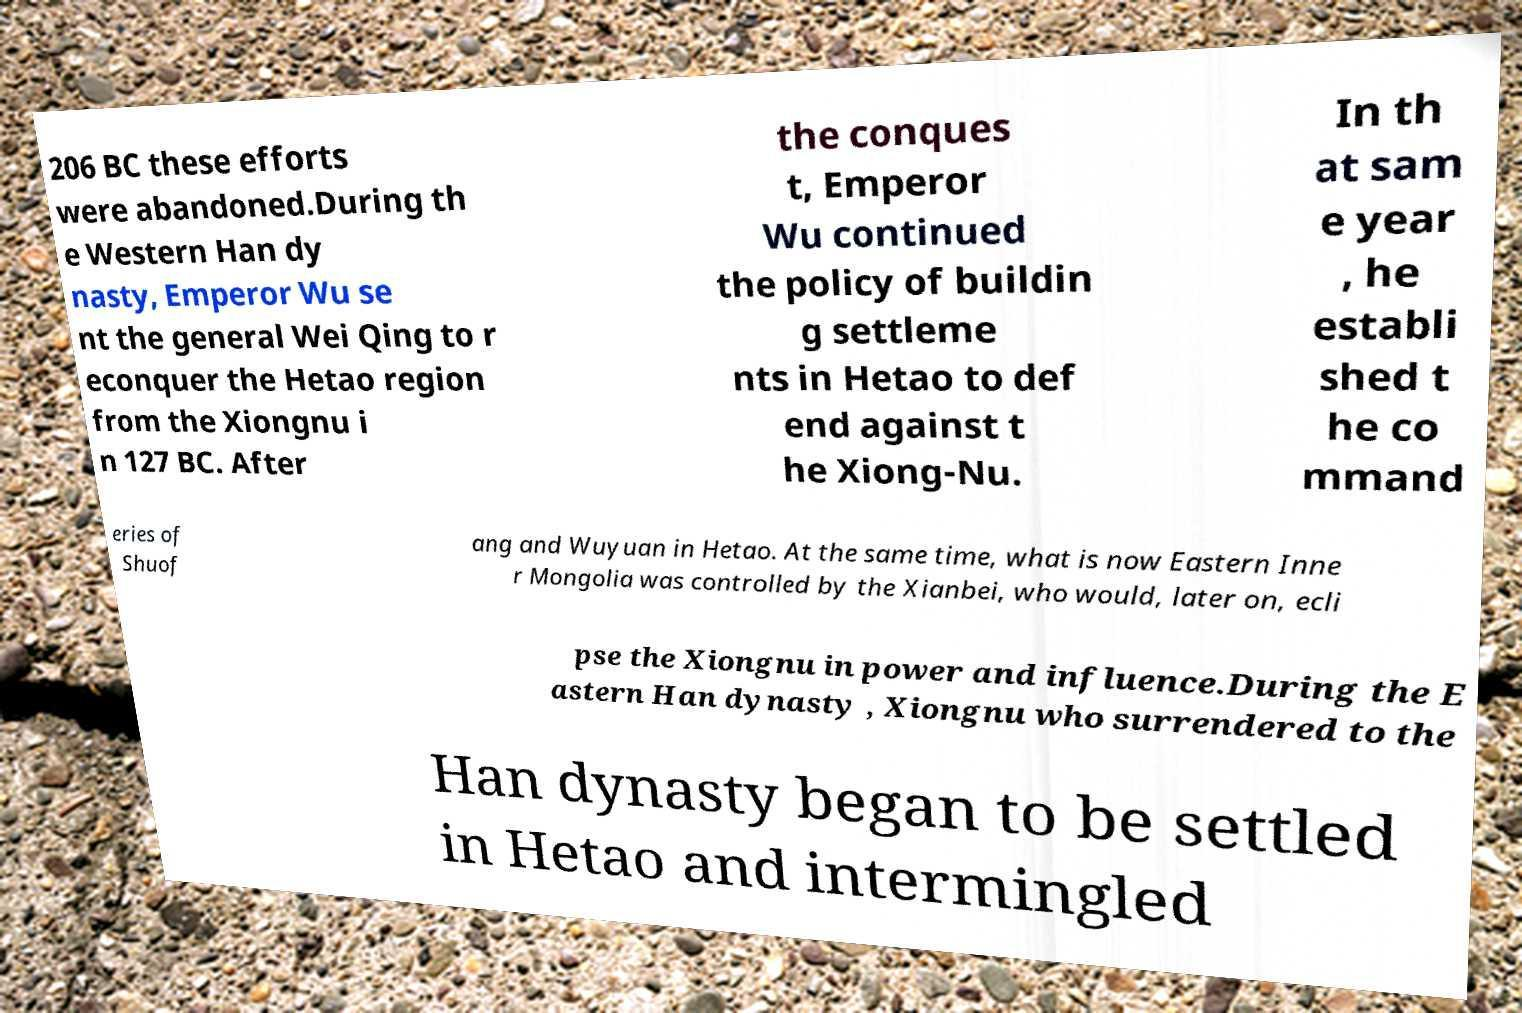Please read and relay the text visible in this image. What does it say? 206 BC these efforts were abandoned.During th e Western Han dy nasty, Emperor Wu se nt the general Wei Qing to r econquer the Hetao region from the Xiongnu i n 127 BC. After the conques t, Emperor Wu continued the policy of buildin g settleme nts in Hetao to def end against t he Xiong-Nu. In th at sam e year , he establi shed t he co mmand eries of Shuof ang and Wuyuan in Hetao. At the same time, what is now Eastern Inne r Mongolia was controlled by the Xianbei, who would, later on, ecli pse the Xiongnu in power and influence.During the E astern Han dynasty , Xiongnu who surrendered to the Han dynasty began to be settled in Hetao and intermingled 